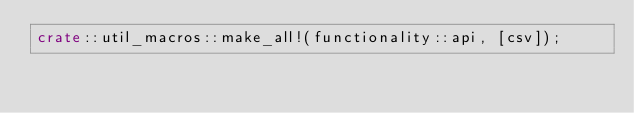<code> <loc_0><loc_0><loc_500><loc_500><_Rust_>crate::util_macros::make_all!(functionality::api, [csv]);
</code> 